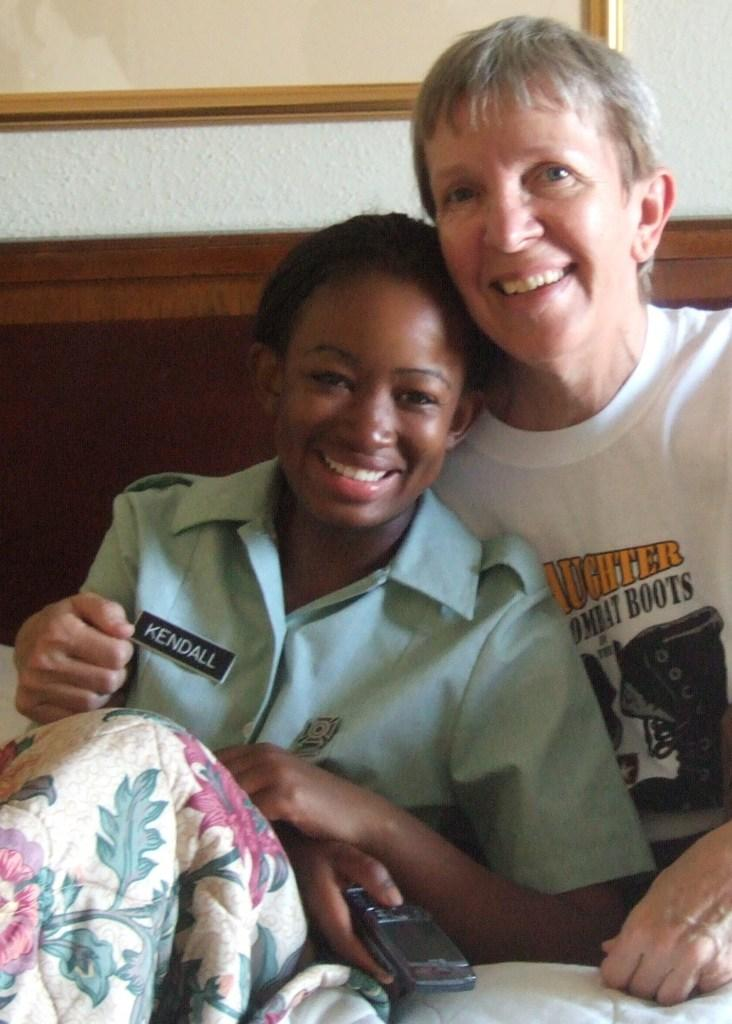What is the primary subject of the image? There is a woman in the image. Are there any other people present in the image? Yes, there is a child in the image. What can be seen in the background of the image? There is a wall visible in the background of the image. What type of joke is the woman telling the child in the image? There is no indication in the image that the woman is telling a joke to the child. Can you provide an example of the army's involvement in the image? There is no reference to an army or any military presence in the image. 